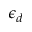<formula> <loc_0><loc_0><loc_500><loc_500>\epsilon _ { d }</formula> 